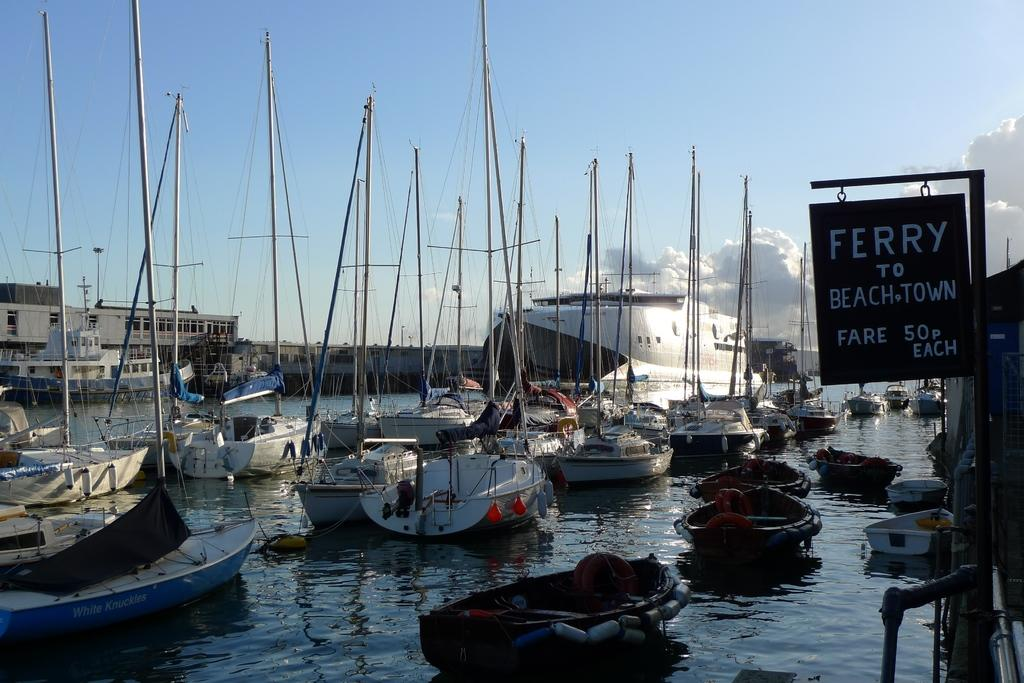<image>
Relay a brief, clear account of the picture shown. Among a bunch of boats a sign reads Ferry to Beachtown. 